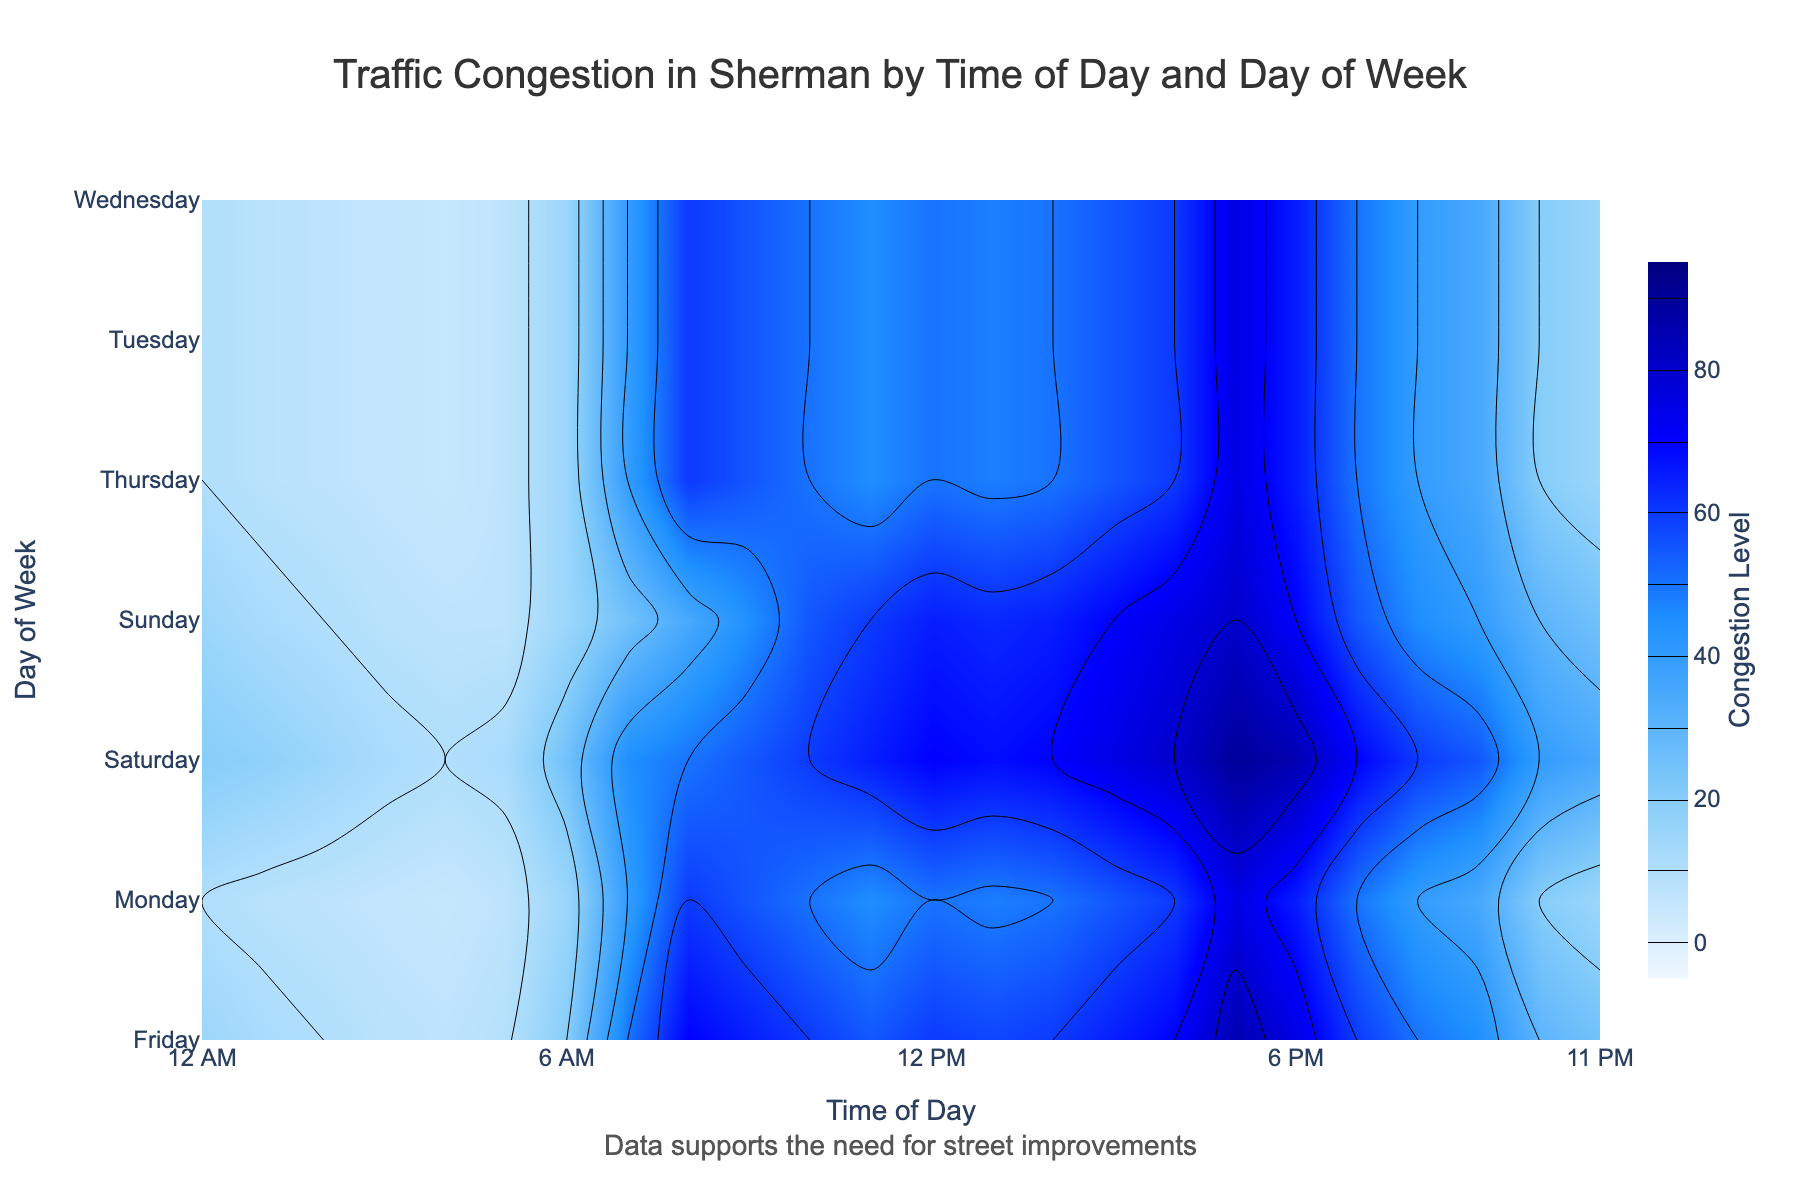What's the peak congestion level on Friday? Look for the highest color intensity on Friday's row and read the associated congestion level from the color bar. The peak level appears at 5 PM.
Answer: 85 At what time of day does traffic congestion start to increase significantly on weekdays? Observe the colors from light to dark along the x-axis (Time of Day) for Monday to Friday. Significant congestion increase is seen starting at around 7 AM.
Answer: 7 AM How does the traffic congestion on Saturday at 3 PM compare to that on Monday at 3 PM? Compare the colors (or contour values) at 3 PM for both Saturday and Monday. The color for Saturday at 3 PM is darker, indicating higher congestion.
Answer: Higher on Saturday What trend can you observe in traffic congestion levels starting from early morning (6 AM) to evening (6 PM) on weekdays? Observe the transition of colors from morning to evening (6 AM to 6 PM) on weekdays. Congestion starts low, increases sharply around 7 AM, peaks towards 5 PM, and then decreases.
Answer: Increasing, peak at 5 PM Which day of the week has the least varying congestion levels throughout the day? Look for the day with the most uniform color along the time axis. Sunday has the least variation based on the contour plot.
Answer: Sunday 